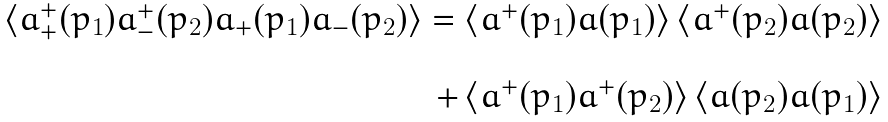Convert formula to latex. <formula><loc_0><loc_0><loc_500><loc_500>\begin{array} { r } \left \langle a _ { + } ^ { + } ( p _ { 1 } ) a _ { - } ^ { + } ( p _ { 2 } ) a _ { + } ( p _ { 1 } ) a _ { - } ( p _ { 2 } ) \right \rangle = \left \langle a ^ { + } ( p _ { 1 } ) a ( p _ { 1 } ) \right \rangle \left \langle a ^ { + } ( p _ { 2 } ) a ( p _ { 2 } ) \right \rangle \\ \\ + \left \langle a ^ { + } ( p _ { 1 } ) a ^ { + } ( p _ { 2 } ) \right \rangle \left \langle a ( p _ { 2 } ) a ( p _ { 1 } ) \right \rangle \end{array}</formula> 